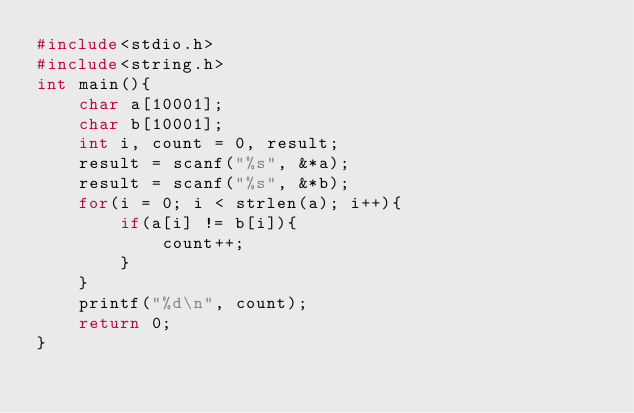<code> <loc_0><loc_0><loc_500><loc_500><_C_>#include<stdio.h>
#include<string.h>
int main(){
    char a[10001];
    char b[10001];
    int i, count = 0, result;
    result = scanf("%s", &*a);
    result = scanf("%s", &*b);
    for(i = 0; i < strlen(a); i++){
        if(a[i] != b[i]){
            count++;
        }
    }
    printf("%d\n", count);
    return 0;
}</code> 